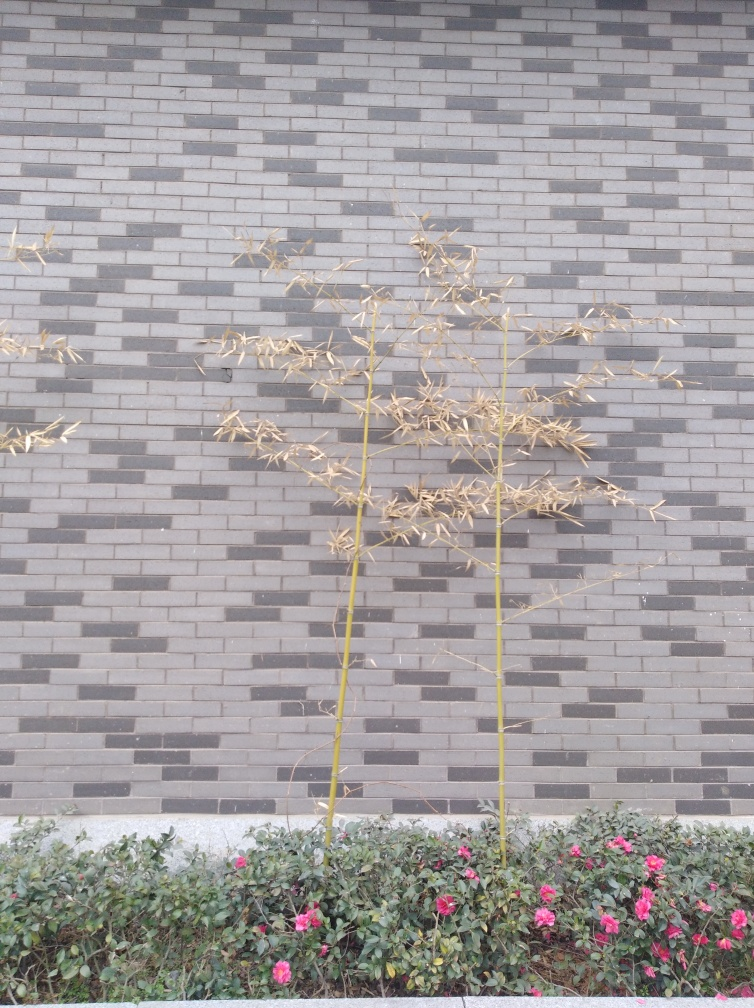What time of year does this picture suggest? The image suggests a transition between seasons, likely late autumn or early winter. This is indicated by the presence of drying, withered plants alongside vibrant flowers, hinting at recent changes in temperature or other environmental conditions. 